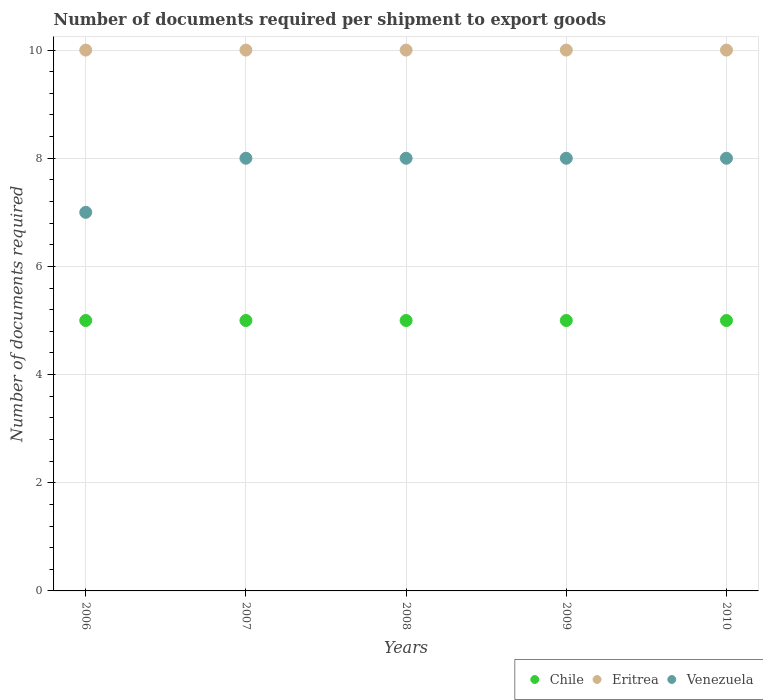Is the number of dotlines equal to the number of legend labels?
Give a very brief answer. Yes. What is the number of documents required per shipment to export goods in Chile in 2009?
Provide a short and direct response. 5. Across all years, what is the maximum number of documents required per shipment to export goods in Chile?
Provide a succinct answer. 5. Across all years, what is the minimum number of documents required per shipment to export goods in Venezuela?
Provide a short and direct response. 7. In which year was the number of documents required per shipment to export goods in Eritrea maximum?
Your answer should be compact. 2006. In which year was the number of documents required per shipment to export goods in Chile minimum?
Offer a terse response. 2006. What is the total number of documents required per shipment to export goods in Eritrea in the graph?
Offer a very short reply. 50. What is the difference between the number of documents required per shipment to export goods in Venezuela in 2008 and that in 2010?
Keep it short and to the point. 0. What is the difference between the number of documents required per shipment to export goods in Chile in 2006 and the number of documents required per shipment to export goods in Eritrea in 2007?
Provide a succinct answer. -5. In the year 2007, what is the difference between the number of documents required per shipment to export goods in Venezuela and number of documents required per shipment to export goods in Chile?
Your response must be concise. 3. In how many years, is the number of documents required per shipment to export goods in Venezuela greater than 3.6?
Keep it short and to the point. 5. What is the ratio of the number of documents required per shipment to export goods in Chile in 2009 to that in 2010?
Your answer should be very brief. 1. Is the difference between the number of documents required per shipment to export goods in Venezuela in 2007 and 2008 greater than the difference between the number of documents required per shipment to export goods in Chile in 2007 and 2008?
Provide a succinct answer. No. What is the difference between the highest and the lowest number of documents required per shipment to export goods in Venezuela?
Give a very brief answer. 1. Does the number of documents required per shipment to export goods in Venezuela monotonically increase over the years?
Give a very brief answer. No. Is the number of documents required per shipment to export goods in Eritrea strictly greater than the number of documents required per shipment to export goods in Chile over the years?
Your response must be concise. Yes. Does the graph contain grids?
Ensure brevity in your answer.  Yes. How are the legend labels stacked?
Provide a short and direct response. Horizontal. What is the title of the graph?
Offer a very short reply. Number of documents required per shipment to export goods. What is the label or title of the Y-axis?
Your answer should be very brief. Number of documents required. What is the Number of documents required in Chile in 2006?
Offer a very short reply. 5. What is the Number of documents required of Chile in 2007?
Your answer should be very brief. 5. What is the Number of documents required of Venezuela in 2007?
Your answer should be compact. 8. What is the Number of documents required of Chile in 2008?
Your response must be concise. 5. What is the Number of documents required in Eritrea in 2008?
Make the answer very short. 10. What is the Number of documents required in Venezuela in 2008?
Your answer should be very brief. 8. What is the Number of documents required in Chile in 2009?
Make the answer very short. 5. What is the Number of documents required of Venezuela in 2009?
Offer a terse response. 8. What is the Number of documents required of Chile in 2010?
Provide a succinct answer. 5. What is the Number of documents required of Venezuela in 2010?
Provide a succinct answer. 8. Across all years, what is the maximum Number of documents required in Venezuela?
Provide a succinct answer. 8. Across all years, what is the minimum Number of documents required in Eritrea?
Provide a short and direct response. 10. What is the total Number of documents required of Eritrea in the graph?
Your answer should be compact. 50. What is the difference between the Number of documents required in Chile in 2006 and that in 2007?
Give a very brief answer. 0. What is the difference between the Number of documents required in Chile in 2006 and that in 2008?
Provide a succinct answer. 0. What is the difference between the Number of documents required of Eritrea in 2006 and that in 2009?
Ensure brevity in your answer.  0. What is the difference between the Number of documents required of Chile in 2007 and that in 2008?
Your response must be concise. 0. What is the difference between the Number of documents required in Chile in 2007 and that in 2009?
Your answer should be compact. 0. What is the difference between the Number of documents required in Eritrea in 2007 and that in 2009?
Keep it short and to the point. 0. What is the difference between the Number of documents required of Venezuela in 2007 and that in 2009?
Provide a short and direct response. 0. What is the difference between the Number of documents required in Chile in 2007 and that in 2010?
Your answer should be very brief. 0. What is the difference between the Number of documents required in Venezuela in 2007 and that in 2010?
Your response must be concise. 0. What is the difference between the Number of documents required in Eritrea in 2008 and that in 2009?
Provide a succinct answer. 0. What is the difference between the Number of documents required of Eritrea in 2008 and that in 2010?
Keep it short and to the point. 0. What is the difference between the Number of documents required in Chile in 2009 and that in 2010?
Provide a succinct answer. 0. What is the difference between the Number of documents required in Eritrea in 2009 and that in 2010?
Offer a very short reply. 0. What is the difference between the Number of documents required of Chile in 2006 and the Number of documents required of Venezuela in 2008?
Provide a short and direct response. -3. What is the difference between the Number of documents required in Eritrea in 2006 and the Number of documents required in Venezuela in 2008?
Your response must be concise. 2. What is the difference between the Number of documents required of Chile in 2006 and the Number of documents required of Eritrea in 2009?
Your answer should be very brief. -5. What is the difference between the Number of documents required of Chile in 2006 and the Number of documents required of Venezuela in 2009?
Your answer should be compact. -3. What is the difference between the Number of documents required of Chile in 2006 and the Number of documents required of Eritrea in 2010?
Offer a terse response. -5. What is the difference between the Number of documents required in Chile in 2007 and the Number of documents required in Eritrea in 2008?
Provide a short and direct response. -5. What is the difference between the Number of documents required in Chile in 2007 and the Number of documents required in Venezuela in 2008?
Your response must be concise. -3. What is the difference between the Number of documents required of Chile in 2007 and the Number of documents required of Eritrea in 2009?
Provide a succinct answer. -5. What is the difference between the Number of documents required of Chile in 2007 and the Number of documents required of Venezuela in 2010?
Keep it short and to the point. -3. What is the difference between the Number of documents required in Eritrea in 2007 and the Number of documents required in Venezuela in 2010?
Your answer should be very brief. 2. What is the difference between the Number of documents required in Chile in 2008 and the Number of documents required in Eritrea in 2009?
Your response must be concise. -5. What is the difference between the Number of documents required in Eritrea in 2008 and the Number of documents required in Venezuela in 2009?
Give a very brief answer. 2. What is the difference between the Number of documents required in Chile in 2008 and the Number of documents required in Venezuela in 2010?
Keep it short and to the point. -3. What is the difference between the Number of documents required in Eritrea in 2008 and the Number of documents required in Venezuela in 2010?
Make the answer very short. 2. What is the difference between the Number of documents required of Eritrea in 2009 and the Number of documents required of Venezuela in 2010?
Make the answer very short. 2. What is the average Number of documents required of Chile per year?
Your response must be concise. 5. What is the average Number of documents required in Eritrea per year?
Your response must be concise. 10. In the year 2006, what is the difference between the Number of documents required of Eritrea and Number of documents required of Venezuela?
Keep it short and to the point. 3. In the year 2007, what is the difference between the Number of documents required in Chile and Number of documents required in Eritrea?
Provide a succinct answer. -5. In the year 2007, what is the difference between the Number of documents required of Chile and Number of documents required of Venezuela?
Provide a succinct answer. -3. In the year 2008, what is the difference between the Number of documents required of Chile and Number of documents required of Eritrea?
Keep it short and to the point. -5. In the year 2008, what is the difference between the Number of documents required of Chile and Number of documents required of Venezuela?
Provide a short and direct response. -3. In the year 2009, what is the difference between the Number of documents required of Chile and Number of documents required of Eritrea?
Your answer should be compact. -5. In the year 2009, what is the difference between the Number of documents required of Chile and Number of documents required of Venezuela?
Provide a succinct answer. -3. In the year 2010, what is the difference between the Number of documents required of Chile and Number of documents required of Venezuela?
Provide a succinct answer. -3. In the year 2010, what is the difference between the Number of documents required of Eritrea and Number of documents required of Venezuela?
Ensure brevity in your answer.  2. What is the ratio of the Number of documents required of Eritrea in 2006 to that in 2008?
Offer a terse response. 1. What is the ratio of the Number of documents required of Chile in 2006 to that in 2010?
Your answer should be compact. 1. What is the ratio of the Number of documents required of Eritrea in 2006 to that in 2010?
Your answer should be very brief. 1. What is the ratio of the Number of documents required in Venezuela in 2006 to that in 2010?
Keep it short and to the point. 0.88. What is the ratio of the Number of documents required of Chile in 2007 to that in 2008?
Your answer should be compact. 1. What is the ratio of the Number of documents required of Eritrea in 2007 to that in 2008?
Provide a succinct answer. 1. What is the ratio of the Number of documents required of Chile in 2007 to that in 2009?
Make the answer very short. 1. What is the ratio of the Number of documents required of Venezuela in 2007 to that in 2009?
Provide a succinct answer. 1. What is the ratio of the Number of documents required of Chile in 2007 to that in 2010?
Provide a short and direct response. 1. What is the ratio of the Number of documents required of Eritrea in 2007 to that in 2010?
Keep it short and to the point. 1. What is the ratio of the Number of documents required of Eritrea in 2008 to that in 2009?
Your answer should be compact. 1. What is the ratio of the Number of documents required of Venezuela in 2008 to that in 2009?
Make the answer very short. 1. What is the ratio of the Number of documents required of Venezuela in 2008 to that in 2010?
Offer a very short reply. 1. What is the ratio of the Number of documents required of Chile in 2009 to that in 2010?
Provide a succinct answer. 1. What is the ratio of the Number of documents required of Eritrea in 2009 to that in 2010?
Ensure brevity in your answer.  1. What is the ratio of the Number of documents required of Venezuela in 2009 to that in 2010?
Your response must be concise. 1. What is the difference between the highest and the second highest Number of documents required in Chile?
Your response must be concise. 0. What is the difference between the highest and the lowest Number of documents required in Chile?
Offer a very short reply. 0. What is the difference between the highest and the lowest Number of documents required in Eritrea?
Keep it short and to the point. 0. What is the difference between the highest and the lowest Number of documents required in Venezuela?
Your response must be concise. 1. 